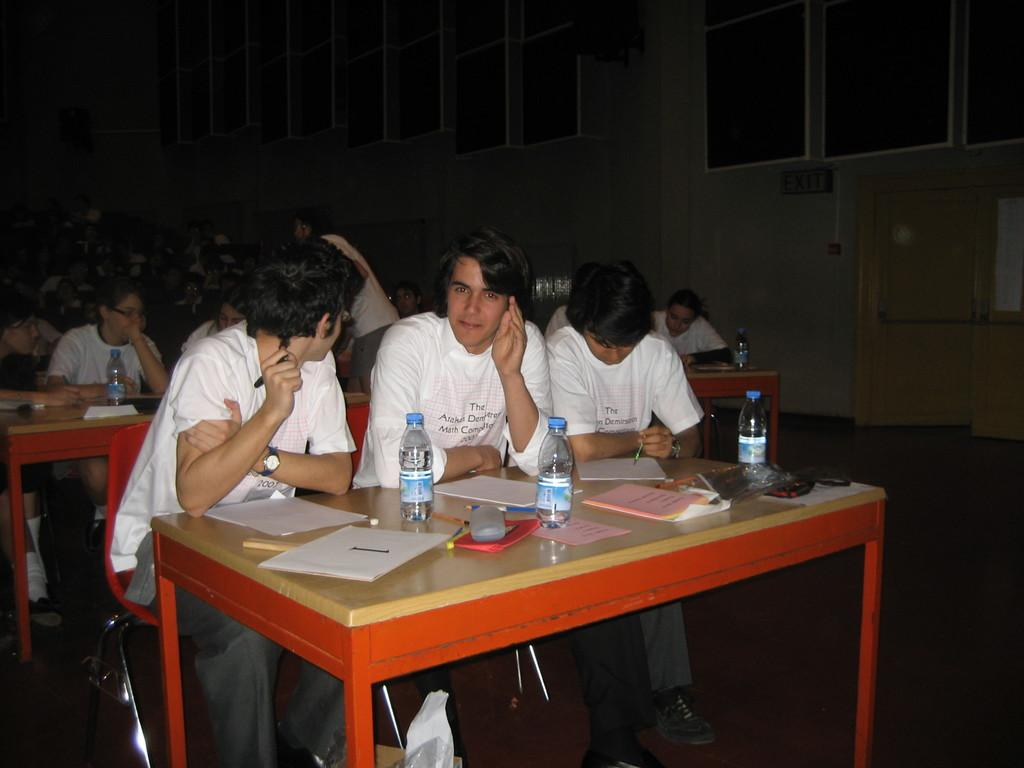What type of structure can be seen in the image? There is a wall in the image. What feature is present in the wall? There is a window in the image. What are the people in the image doing? There are people sitting on chairs in the image. What is on the table in the image? There are papers, books, and bottles on the table. Can you tell me how many quinces are on the table in the image? There are no quinces present in the image. What type of disease is affecting the people sitting on chairs in the image? There is no indication of any disease affecting the people in the image. 